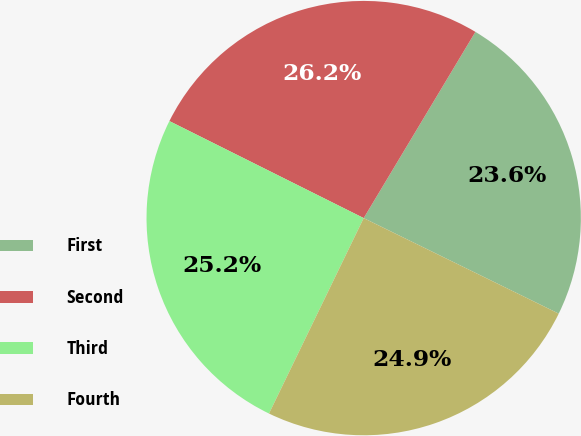Convert chart to OTSL. <chart><loc_0><loc_0><loc_500><loc_500><pie_chart><fcel>First<fcel>Second<fcel>Third<fcel>Fourth<nl><fcel>23.65%<fcel>26.23%<fcel>25.19%<fcel>24.93%<nl></chart> 